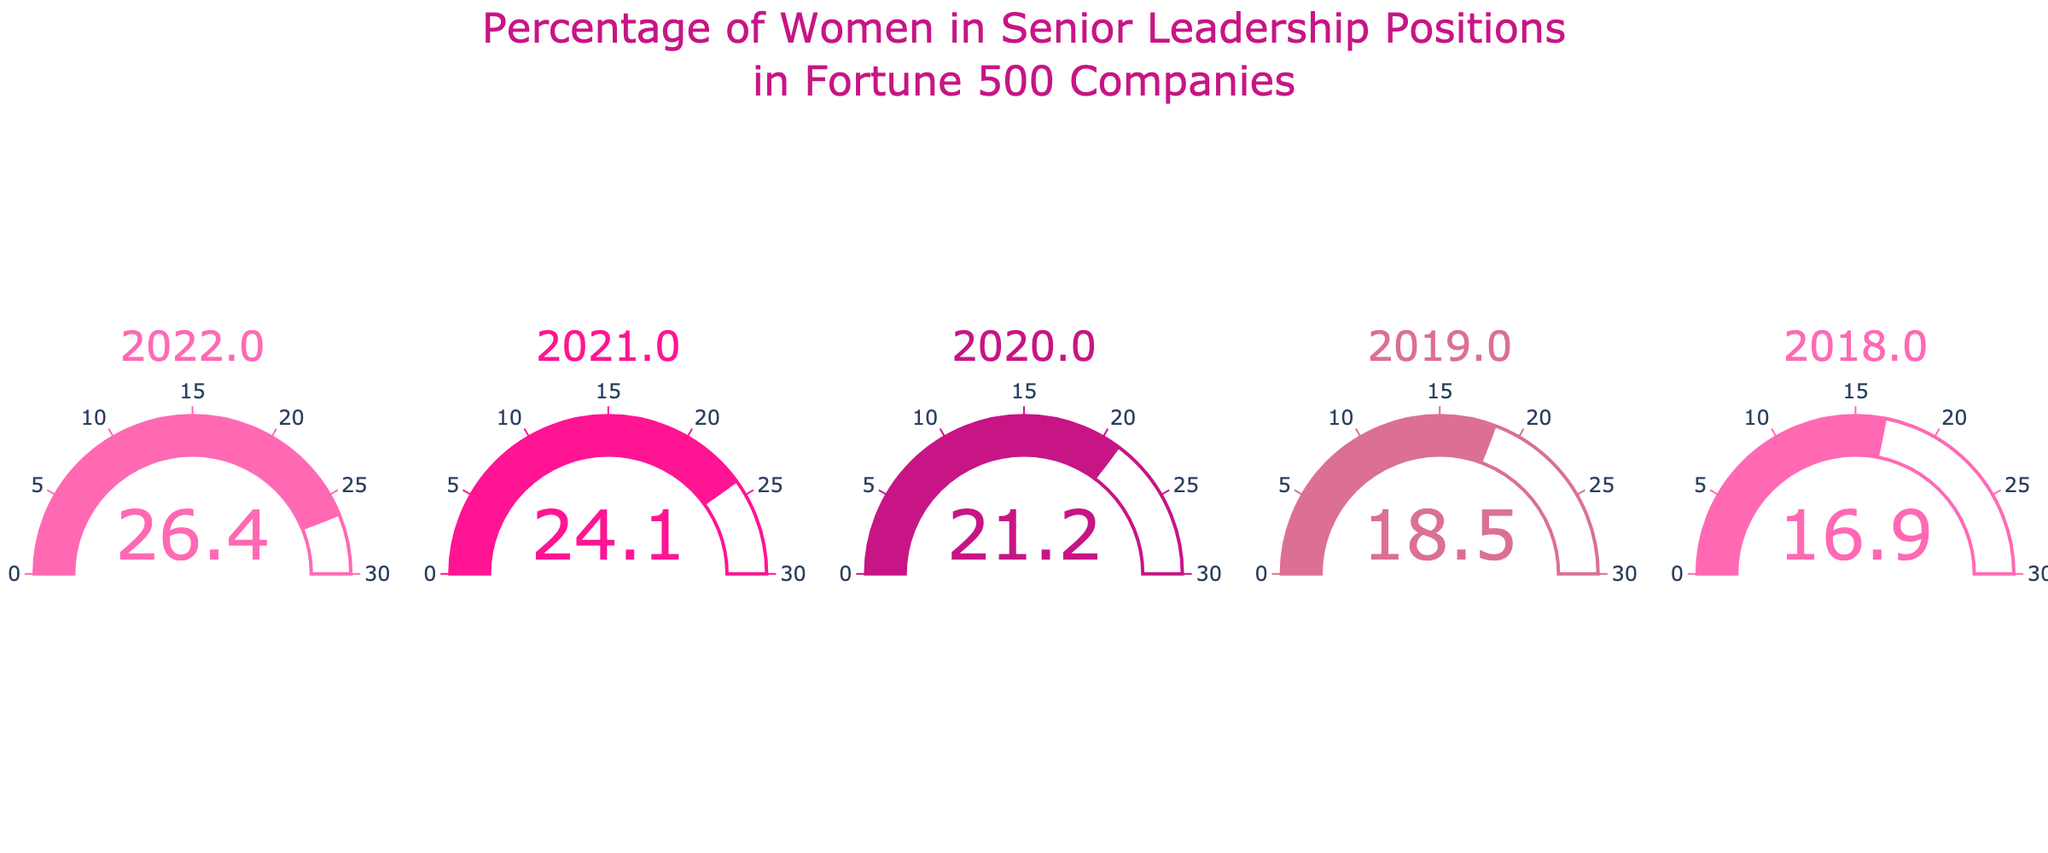What's the title of the figure? The title is usually located at the top of the figure and summarizes the main theme, which is "Percentage of Women in Senior Leadership Positions in Fortune 500 Companies".
Answer: Percentage of Women in Senior Leadership Positions in Fortune 500 Companies How many gauges are there in the figure? By counting the number of gauge charts displayed in the figure, you can determine that there are five separate gauges, one for each year.
Answer: 5 What is the percentage of women in senior leadership positions in 2020? Find the gauge labeled "2020". The value shown on this gauge represents the percentage of women in senior leadership positions for that year.
Answer: 21.2% What is the trend of women's representation in senior leadership positions from 2018 to 2022? Review the percentages from the gauges for each year from 2018 to 2022: 16.9%, 18.5%, 21.2%, 24.1%, and 26.4%. Notice that the percentages have consistently increased each year.
Answer: Increasing What is the average percentage of women in senior leadership positions over the five years? Add the percentages for the five years: 16.9 + 18.5 + 21.2 + 24.1 + 26.4. Then divide by 5 to find the average.
Answer: (16.9 + 18.5 + 21.2 + 24.1 + 26.4) / 5 = 21.42% Which year had the highest percentage of women in senior leadership positions? Identify the gauge with the highest value. The gauge for 2022 shows the highest percentage, which is 26.4%.
Answer: 2022 What is the difference in the percentage of women in senior leadership positions between 2018 and 2022? Subtract the 2018 percentage (16.9%) from the 2022 percentage (26.4%) to find the difference.
Answer: 26.4% - 16.9% = 9.5% By how much did the percentage of women in senior leadership increase from 2019 to 2021? Subtract the 2019 percentage (18.5%) from the 2021 percentage (24.1%) to find the increase.
Answer: 24.1% - 18.5% = 5.6% Which year saw the smallest annual increase in the percentage of women in senior leadership positions compared to the previous year? Calculate the annual increases and see which one is the smallest: 2019-2018 (18.5% - 16.9% = 1.6%), 2020-2019 (21.2% - 18.5% = 2.7%), 2021-2020 (24.1% - 21.2% = 2.9%), 2022-2021 (26.4% - 24.1% = 2.3%). The smallest increase is from 2018 to 2019.
Answer: 2019 